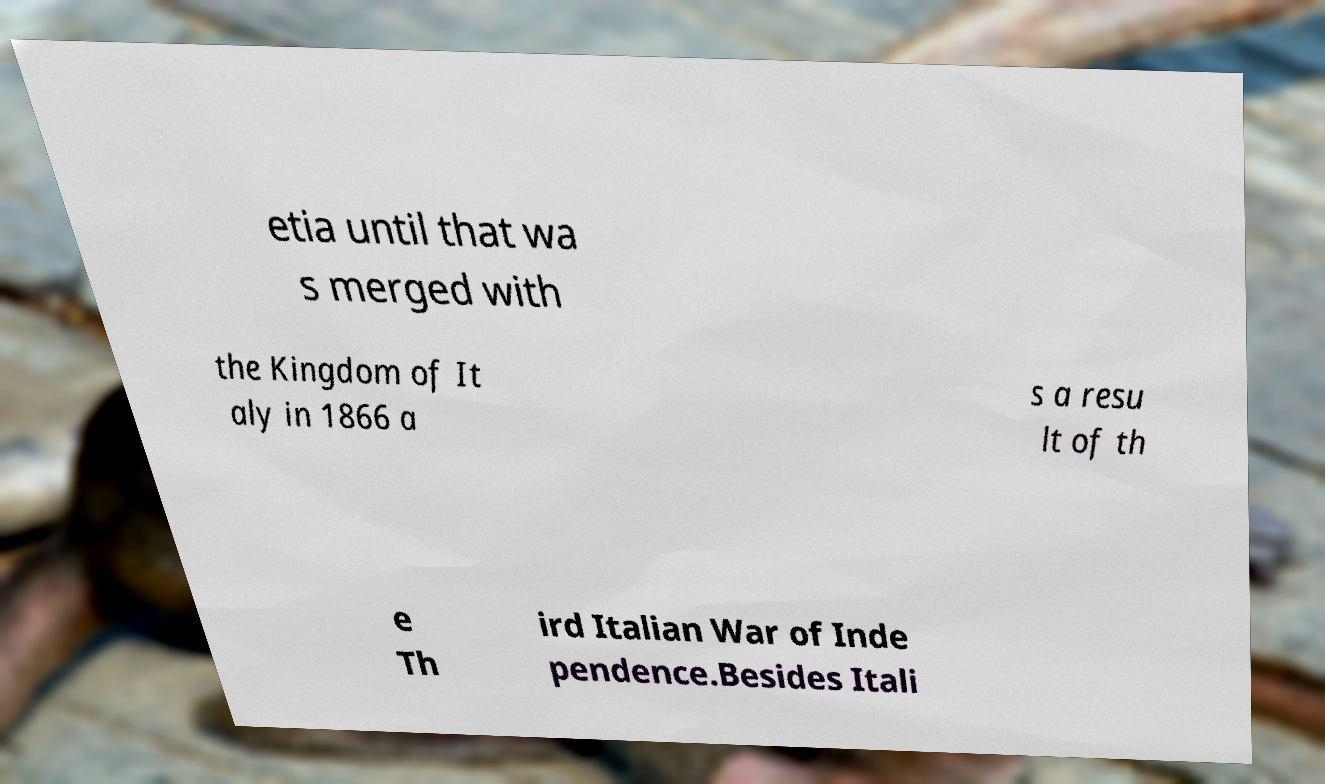Can you accurately transcribe the text from the provided image for me? etia until that wa s merged with the Kingdom of It aly in 1866 a s a resu lt of th e Th ird Italian War of Inde pendence.Besides Itali 